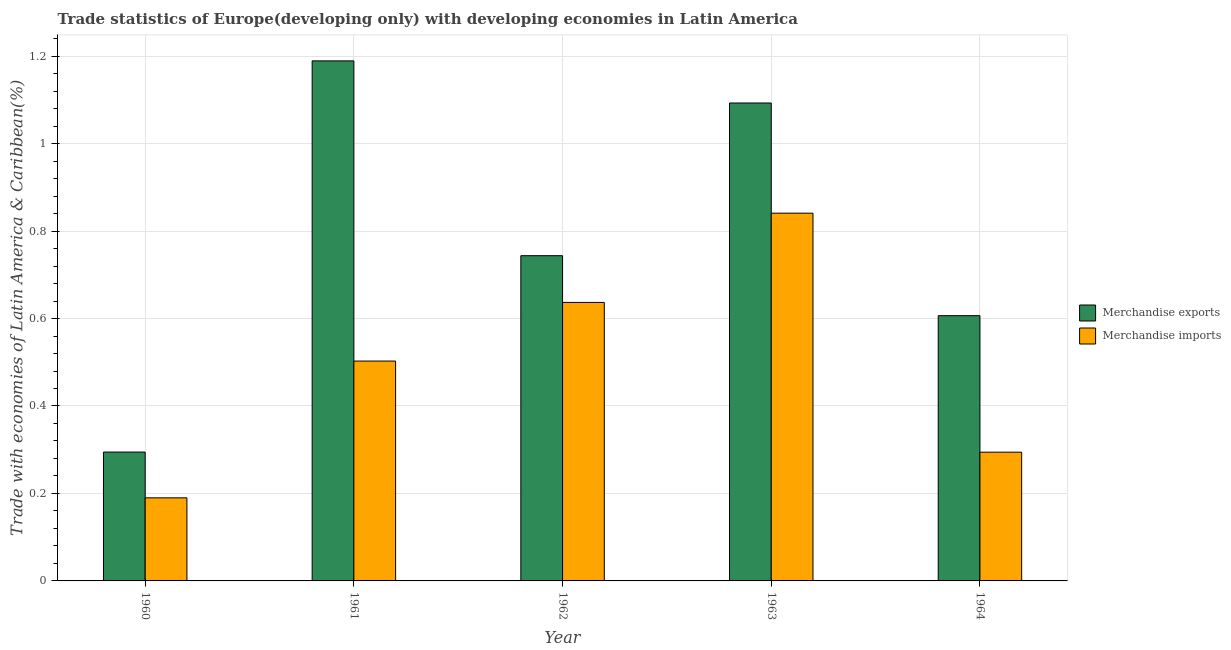How many different coloured bars are there?
Keep it short and to the point. 2. How many groups of bars are there?
Your answer should be compact. 5. Are the number of bars per tick equal to the number of legend labels?
Give a very brief answer. Yes. Are the number of bars on each tick of the X-axis equal?
Your answer should be compact. Yes. In how many cases, is the number of bars for a given year not equal to the number of legend labels?
Provide a short and direct response. 0. What is the merchandise imports in 1962?
Give a very brief answer. 0.64. Across all years, what is the maximum merchandise exports?
Your response must be concise. 1.19. Across all years, what is the minimum merchandise imports?
Ensure brevity in your answer.  0.19. What is the total merchandise imports in the graph?
Your answer should be compact. 2.46. What is the difference between the merchandise exports in 1960 and that in 1961?
Offer a very short reply. -0.89. What is the difference between the merchandise exports in 1963 and the merchandise imports in 1960?
Give a very brief answer. 0.8. What is the average merchandise exports per year?
Provide a succinct answer. 0.79. In the year 1963, what is the difference between the merchandise imports and merchandise exports?
Provide a succinct answer. 0. What is the ratio of the merchandise imports in 1963 to that in 1964?
Provide a short and direct response. 2.86. What is the difference between the highest and the second highest merchandise imports?
Your response must be concise. 0.2. What is the difference between the highest and the lowest merchandise imports?
Make the answer very short. 0.65. In how many years, is the merchandise exports greater than the average merchandise exports taken over all years?
Your response must be concise. 2. What is the difference between two consecutive major ticks on the Y-axis?
Offer a very short reply. 0.2. Where does the legend appear in the graph?
Your answer should be very brief. Center right. How are the legend labels stacked?
Ensure brevity in your answer.  Vertical. What is the title of the graph?
Your answer should be very brief. Trade statistics of Europe(developing only) with developing economies in Latin America. Does "Forest" appear as one of the legend labels in the graph?
Offer a very short reply. No. What is the label or title of the Y-axis?
Provide a short and direct response. Trade with economies of Latin America & Caribbean(%). What is the Trade with economies of Latin America & Caribbean(%) in Merchandise exports in 1960?
Give a very brief answer. 0.29. What is the Trade with economies of Latin America & Caribbean(%) of Merchandise imports in 1960?
Provide a succinct answer. 0.19. What is the Trade with economies of Latin America & Caribbean(%) of Merchandise exports in 1961?
Your answer should be very brief. 1.19. What is the Trade with economies of Latin America & Caribbean(%) of Merchandise imports in 1961?
Your response must be concise. 0.5. What is the Trade with economies of Latin America & Caribbean(%) in Merchandise exports in 1962?
Your answer should be compact. 0.74. What is the Trade with economies of Latin America & Caribbean(%) in Merchandise imports in 1962?
Offer a very short reply. 0.64. What is the Trade with economies of Latin America & Caribbean(%) in Merchandise exports in 1963?
Give a very brief answer. 1.09. What is the Trade with economies of Latin America & Caribbean(%) in Merchandise imports in 1963?
Provide a succinct answer. 0.84. What is the Trade with economies of Latin America & Caribbean(%) of Merchandise exports in 1964?
Keep it short and to the point. 0.61. What is the Trade with economies of Latin America & Caribbean(%) of Merchandise imports in 1964?
Offer a very short reply. 0.29. Across all years, what is the maximum Trade with economies of Latin America & Caribbean(%) of Merchandise exports?
Your answer should be very brief. 1.19. Across all years, what is the maximum Trade with economies of Latin America & Caribbean(%) in Merchandise imports?
Keep it short and to the point. 0.84. Across all years, what is the minimum Trade with economies of Latin America & Caribbean(%) of Merchandise exports?
Give a very brief answer. 0.29. Across all years, what is the minimum Trade with economies of Latin America & Caribbean(%) of Merchandise imports?
Your answer should be compact. 0.19. What is the total Trade with economies of Latin America & Caribbean(%) in Merchandise exports in the graph?
Offer a very short reply. 3.93. What is the total Trade with economies of Latin America & Caribbean(%) of Merchandise imports in the graph?
Your response must be concise. 2.46. What is the difference between the Trade with economies of Latin America & Caribbean(%) of Merchandise exports in 1960 and that in 1961?
Your response must be concise. -0.89. What is the difference between the Trade with economies of Latin America & Caribbean(%) of Merchandise imports in 1960 and that in 1961?
Your response must be concise. -0.31. What is the difference between the Trade with economies of Latin America & Caribbean(%) of Merchandise exports in 1960 and that in 1962?
Provide a short and direct response. -0.45. What is the difference between the Trade with economies of Latin America & Caribbean(%) in Merchandise imports in 1960 and that in 1962?
Offer a very short reply. -0.45. What is the difference between the Trade with economies of Latin America & Caribbean(%) of Merchandise exports in 1960 and that in 1963?
Offer a very short reply. -0.8. What is the difference between the Trade with economies of Latin America & Caribbean(%) in Merchandise imports in 1960 and that in 1963?
Keep it short and to the point. -0.65. What is the difference between the Trade with economies of Latin America & Caribbean(%) in Merchandise exports in 1960 and that in 1964?
Ensure brevity in your answer.  -0.31. What is the difference between the Trade with economies of Latin America & Caribbean(%) of Merchandise imports in 1960 and that in 1964?
Your response must be concise. -0.1. What is the difference between the Trade with economies of Latin America & Caribbean(%) of Merchandise exports in 1961 and that in 1962?
Your answer should be compact. 0.45. What is the difference between the Trade with economies of Latin America & Caribbean(%) of Merchandise imports in 1961 and that in 1962?
Provide a short and direct response. -0.13. What is the difference between the Trade with economies of Latin America & Caribbean(%) of Merchandise exports in 1961 and that in 1963?
Keep it short and to the point. 0.1. What is the difference between the Trade with economies of Latin America & Caribbean(%) in Merchandise imports in 1961 and that in 1963?
Offer a terse response. -0.34. What is the difference between the Trade with economies of Latin America & Caribbean(%) in Merchandise exports in 1961 and that in 1964?
Ensure brevity in your answer.  0.58. What is the difference between the Trade with economies of Latin America & Caribbean(%) in Merchandise imports in 1961 and that in 1964?
Keep it short and to the point. 0.21. What is the difference between the Trade with economies of Latin America & Caribbean(%) of Merchandise exports in 1962 and that in 1963?
Provide a short and direct response. -0.35. What is the difference between the Trade with economies of Latin America & Caribbean(%) in Merchandise imports in 1962 and that in 1963?
Your answer should be very brief. -0.2. What is the difference between the Trade with economies of Latin America & Caribbean(%) in Merchandise exports in 1962 and that in 1964?
Offer a very short reply. 0.14. What is the difference between the Trade with economies of Latin America & Caribbean(%) of Merchandise imports in 1962 and that in 1964?
Your answer should be compact. 0.34. What is the difference between the Trade with economies of Latin America & Caribbean(%) in Merchandise exports in 1963 and that in 1964?
Make the answer very short. 0.49. What is the difference between the Trade with economies of Latin America & Caribbean(%) in Merchandise imports in 1963 and that in 1964?
Your answer should be very brief. 0.55. What is the difference between the Trade with economies of Latin America & Caribbean(%) of Merchandise exports in 1960 and the Trade with economies of Latin America & Caribbean(%) of Merchandise imports in 1961?
Keep it short and to the point. -0.21. What is the difference between the Trade with economies of Latin America & Caribbean(%) in Merchandise exports in 1960 and the Trade with economies of Latin America & Caribbean(%) in Merchandise imports in 1962?
Make the answer very short. -0.34. What is the difference between the Trade with economies of Latin America & Caribbean(%) in Merchandise exports in 1960 and the Trade with economies of Latin America & Caribbean(%) in Merchandise imports in 1963?
Offer a terse response. -0.55. What is the difference between the Trade with economies of Latin America & Caribbean(%) in Merchandise exports in 1961 and the Trade with economies of Latin America & Caribbean(%) in Merchandise imports in 1962?
Your answer should be very brief. 0.55. What is the difference between the Trade with economies of Latin America & Caribbean(%) of Merchandise exports in 1961 and the Trade with economies of Latin America & Caribbean(%) of Merchandise imports in 1963?
Make the answer very short. 0.35. What is the difference between the Trade with economies of Latin America & Caribbean(%) of Merchandise exports in 1961 and the Trade with economies of Latin America & Caribbean(%) of Merchandise imports in 1964?
Your response must be concise. 0.89. What is the difference between the Trade with economies of Latin America & Caribbean(%) in Merchandise exports in 1962 and the Trade with economies of Latin America & Caribbean(%) in Merchandise imports in 1963?
Make the answer very short. -0.1. What is the difference between the Trade with economies of Latin America & Caribbean(%) in Merchandise exports in 1962 and the Trade with economies of Latin America & Caribbean(%) in Merchandise imports in 1964?
Provide a succinct answer. 0.45. What is the difference between the Trade with economies of Latin America & Caribbean(%) in Merchandise exports in 1963 and the Trade with economies of Latin America & Caribbean(%) in Merchandise imports in 1964?
Offer a very short reply. 0.8. What is the average Trade with economies of Latin America & Caribbean(%) in Merchandise exports per year?
Provide a succinct answer. 0.79. What is the average Trade with economies of Latin America & Caribbean(%) in Merchandise imports per year?
Give a very brief answer. 0.49. In the year 1960, what is the difference between the Trade with economies of Latin America & Caribbean(%) of Merchandise exports and Trade with economies of Latin America & Caribbean(%) of Merchandise imports?
Offer a very short reply. 0.1. In the year 1961, what is the difference between the Trade with economies of Latin America & Caribbean(%) of Merchandise exports and Trade with economies of Latin America & Caribbean(%) of Merchandise imports?
Your response must be concise. 0.69. In the year 1962, what is the difference between the Trade with economies of Latin America & Caribbean(%) of Merchandise exports and Trade with economies of Latin America & Caribbean(%) of Merchandise imports?
Your response must be concise. 0.11. In the year 1963, what is the difference between the Trade with economies of Latin America & Caribbean(%) in Merchandise exports and Trade with economies of Latin America & Caribbean(%) in Merchandise imports?
Keep it short and to the point. 0.25. In the year 1964, what is the difference between the Trade with economies of Latin America & Caribbean(%) in Merchandise exports and Trade with economies of Latin America & Caribbean(%) in Merchandise imports?
Provide a short and direct response. 0.31. What is the ratio of the Trade with economies of Latin America & Caribbean(%) of Merchandise exports in 1960 to that in 1961?
Offer a very short reply. 0.25. What is the ratio of the Trade with economies of Latin America & Caribbean(%) in Merchandise imports in 1960 to that in 1961?
Keep it short and to the point. 0.38. What is the ratio of the Trade with economies of Latin America & Caribbean(%) of Merchandise exports in 1960 to that in 1962?
Keep it short and to the point. 0.4. What is the ratio of the Trade with economies of Latin America & Caribbean(%) of Merchandise imports in 1960 to that in 1962?
Offer a terse response. 0.3. What is the ratio of the Trade with economies of Latin America & Caribbean(%) of Merchandise exports in 1960 to that in 1963?
Ensure brevity in your answer.  0.27. What is the ratio of the Trade with economies of Latin America & Caribbean(%) in Merchandise imports in 1960 to that in 1963?
Provide a short and direct response. 0.23. What is the ratio of the Trade with economies of Latin America & Caribbean(%) in Merchandise exports in 1960 to that in 1964?
Give a very brief answer. 0.49. What is the ratio of the Trade with economies of Latin America & Caribbean(%) of Merchandise imports in 1960 to that in 1964?
Make the answer very short. 0.65. What is the ratio of the Trade with economies of Latin America & Caribbean(%) in Merchandise exports in 1961 to that in 1962?
Your response must be concise. 1.6. What is the ratio of the Trade with economies of Latin America & Caribbean(%) in Merchandise imports in 1961 to that in 1962?
Keep it short and to the point. 0.79. What is the ratio of the Trade with economies of Latin America & Caribbean(%) in Merchandise exports in 1961 to that in 1963?
Make the answer very short. 1.09. What is the ratio of the Trade with economies of Latin America & Caribbean(%) of Merchandise imports in 1961 to that in 1963?
Make the answer very short. 0.6. What is the ratio of the Trade with economies of Latin America & Caribbean(%) of Merchandise exports in 1961 to that in 1964?
Your response must be concise. 1.96. What is the ratio of the Trade with economies of Latin America & Caribbean(%) in Merchandise imports in 1961 to that in 1964?
Provide a succinct answer. 1.71. What is the ratio of the Trade with economies of Latin America & Caribbean(%) of Merchandise exports in 1962 to that in 1963?
Keep it short and to the point. 0.68. What is the ratio of the Trade with economies of Latin America & Caribbean(%) in Merchandise imports in 1962 to that in 1963?
Your answer should be very brief. 0.76. What is the ratio of the Trade with economies of Latin America & Caribbean(%) of Merchandise exports in 1962 to that in 1964?
Your answer should be very brief. 1.23. What is the ratio of the Trade with economies of Latin America & Caribbean(%) of Merchandise imports in 1962 to that in 1964?
Make the answer very short. 2.16. What is the ratio of the Trade with economies of Latin America & Caribbean(%) in Merchandise exports in 1963 to that in 1964?
Keep it short and to the point. 1.8. What is the ratio of the Trade with economies of Latin America & Caribbean(%) in Merchandise imports in 1963 to that in 1964?
Provide a succinct answer. 2.86. What is the difference between the highest and the second highest Trade with economies of Latin America & Caribbean(%) of Merchandise exports?
Provide a succinct answer. 0.1. What is the difference between the highest and the second highest Trade with economies of Latin America & Caribbean(%) in Merchandise imports?
Ensure brevity in your answer.  0.2. What is the difference between the highest and the lowest Trade with economies of Latin America & Caribbean(%) in Merchandise exports?
Make the answer very short. 0.89. What is the difference between the highest and the lowest Trade with economies of Latin America & Caribbean(%) of Merchandise imports?
Give a very brief answer. 0.65. 